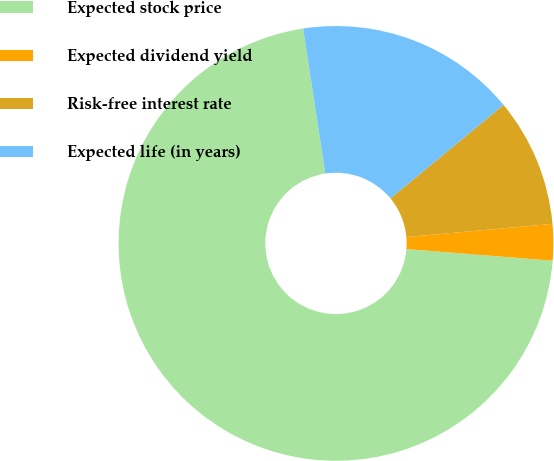Convert chart. <chart><loc_0><loc_0><loc_500><loc_500><pie_chart><fcel>Expected stock price<fcel>Expected dividend yield<fcel>Risk-free interest rate<fcel>Expected life (in years)<nl><fcel>71.31%<fcel>2.7%<fcel>9.56%<fcel>16.42%<nl></chart> 